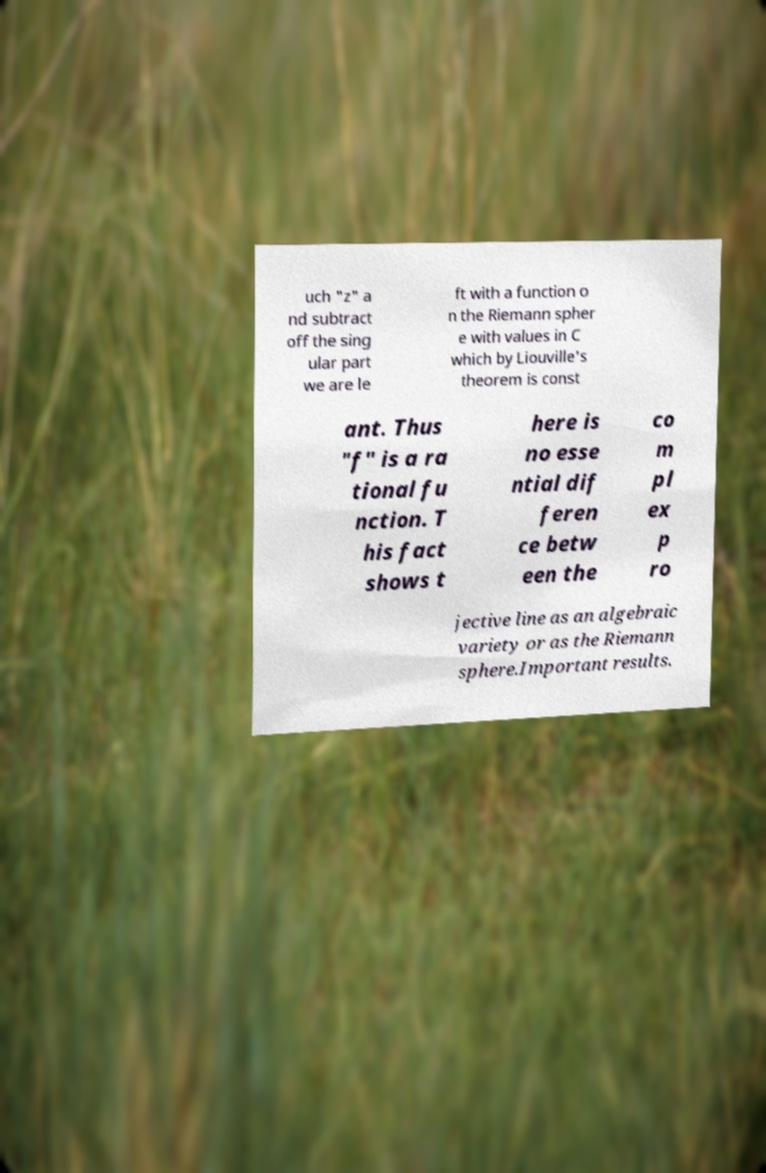Please read and relay the text visible in this image. What does it say? uch "z" a nd subtract off the sing ular part we are le ft with a function o n the Riemann spher e with values in C which by Liouville's theorem is const ant. Thus "f" is a ra tional fu nction. T his fact shows t here is no esse ntial dif feren ce betw een the co m pl ex p ro jective line as an algebraic variety or as the Riemann sphere.Important results. 